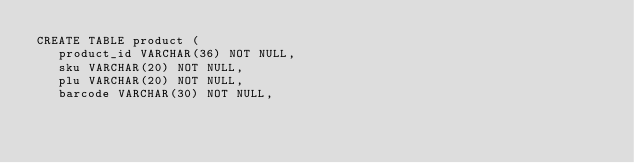<code> <loc_0><loc_0><loc_500><loc_500><_SQL_>CREATE TABLE product (
   product_id VARCHAR(36) NOT NULL,
   sku VARCHAR(20) NOT NULL,
   plu VARCHAR(20) NOT NULL,
   barcode VARCHAR(30) NOT NULL,</code> 